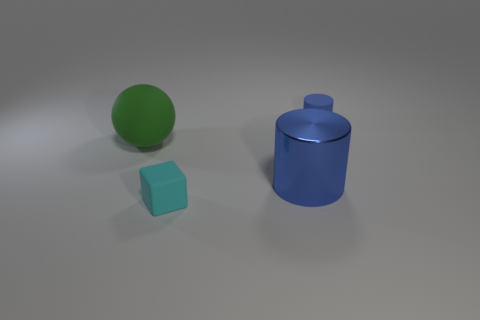Add 2 shiny objects. How many objects exist? 6 Subtract all spheres. How many objects are left? 3 Add 4 green things. How many green things exist? 5 Subtract 0 red cylinders. How many objects are left? 4 Subtract all blue objects. Subtract all blue things. How many objects are left? 0 Add 2 matte balls. How many matte balls are left? 3 